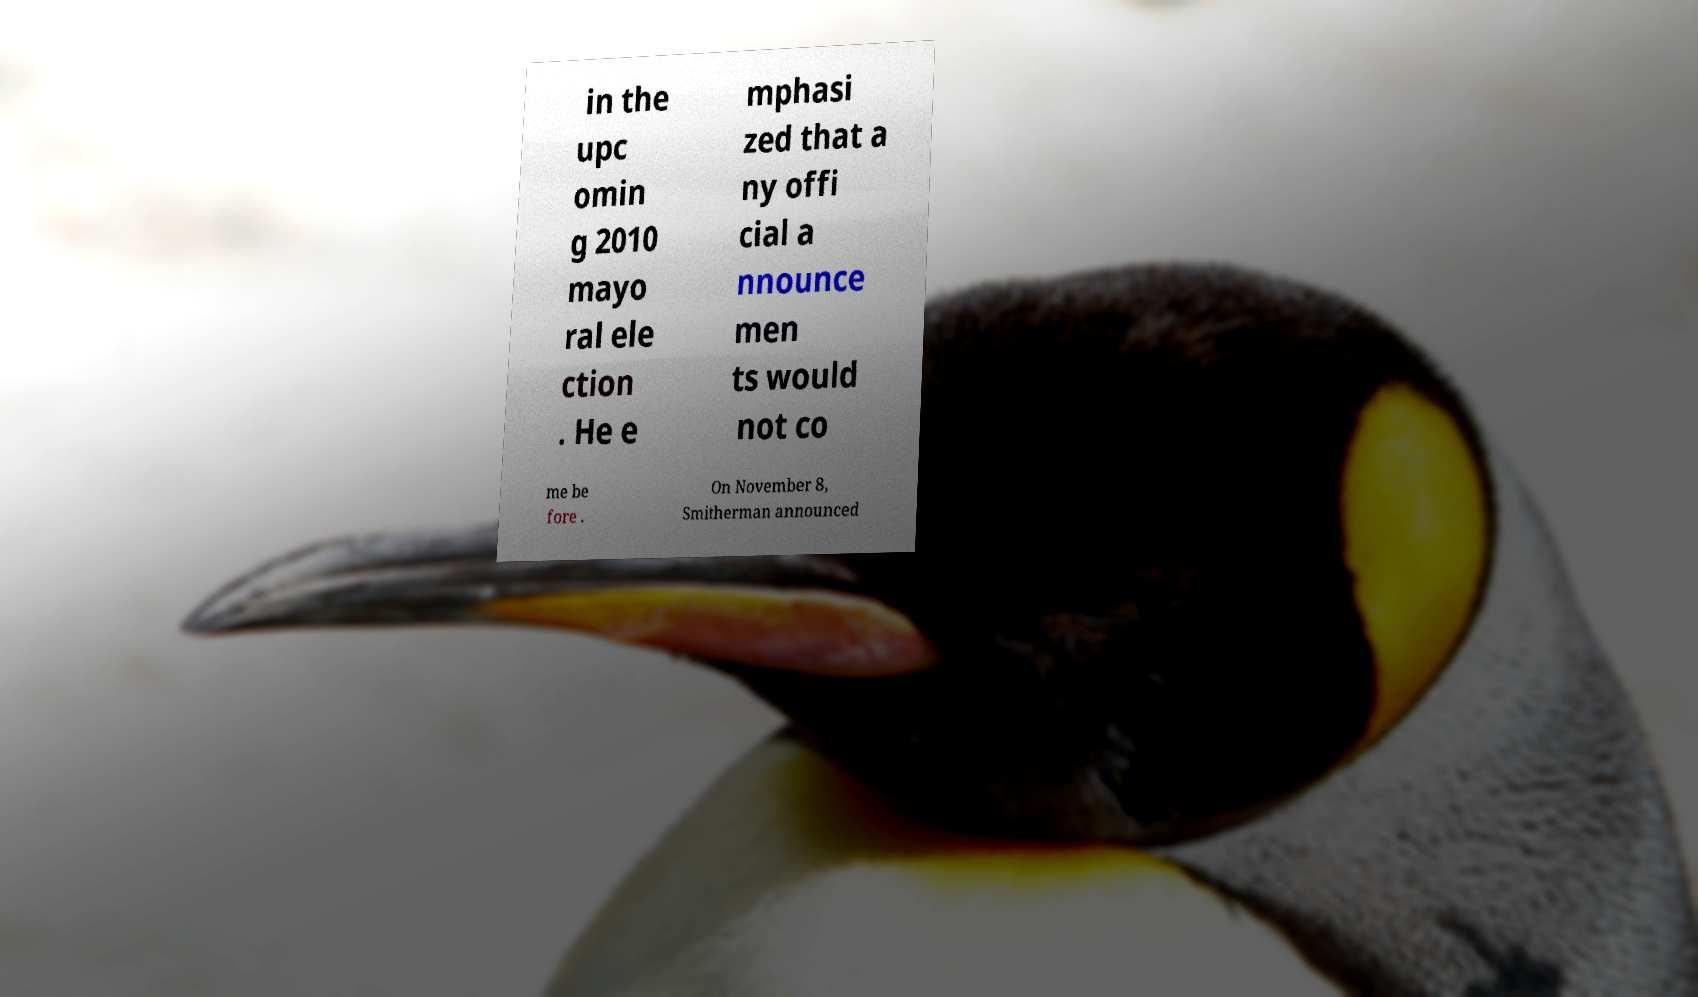Could you assist in decoding the text presented in this image and type it out clearly? in the upc omin g 2010 mayo ral ele ction . He e mphasi zed that a ny offi cial a nnounce men ts would not co me be fore . On November 8, Smitherman announced 